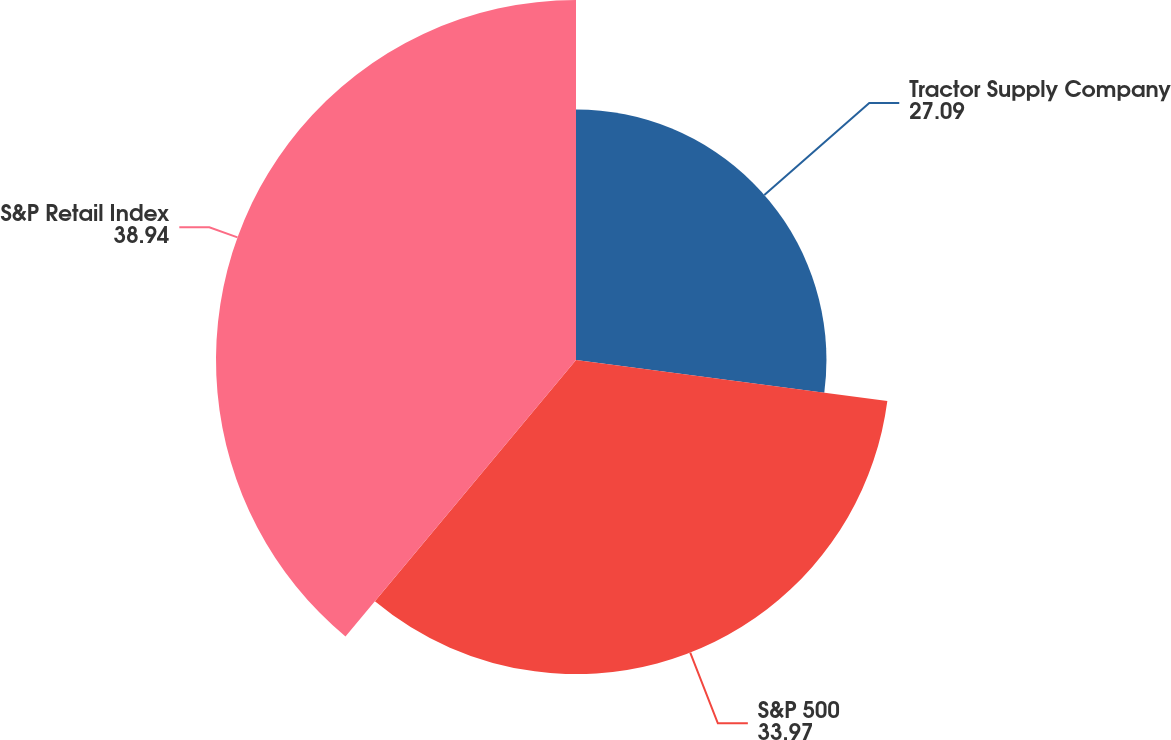Convert chart. <chart><loc_0><loc_0><loc_500><loc_500><pie_chart><fcel>Tractor Supply Company<fcel>S&P 500<fcel>S&P Retail Index<nl><fcel>27.09%<fcel>33.97%<fcel>38.94%<nl></chart> 